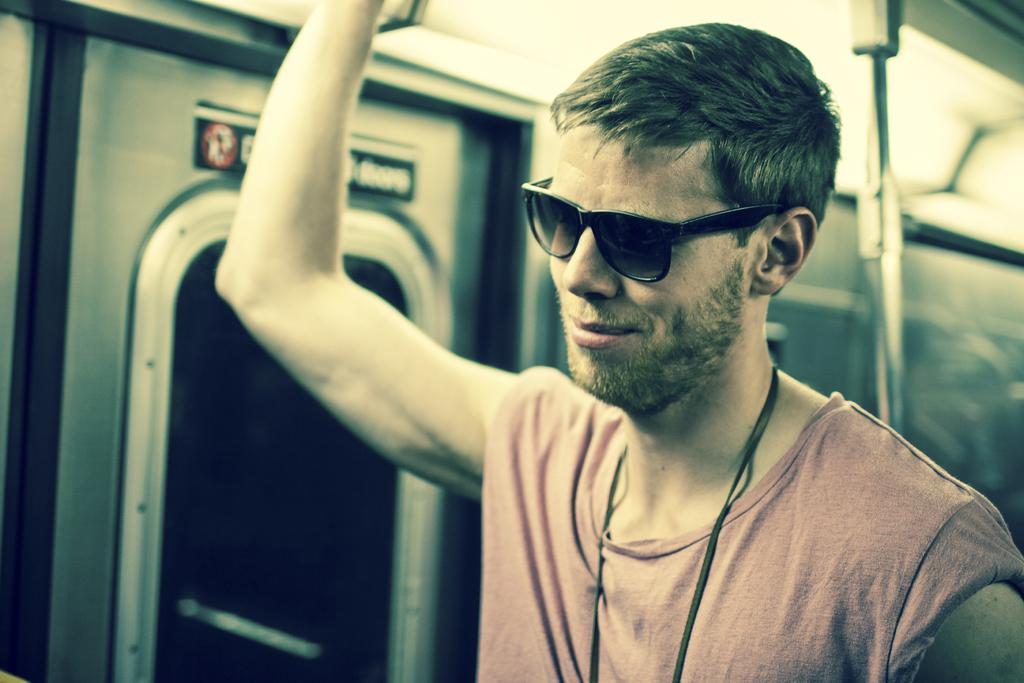What is the main subject of the image? There is a person in the image. What is the person wearing? The person is wearing goggles. What is the person's posture in the image? The person is standing. What can be seen near the person? There is a door beside the person and a pole behind the person. What type of jewel is the person holding in the image? There is no jewel present in the image; the person is wearing goggles and standing near a door and a pole. 